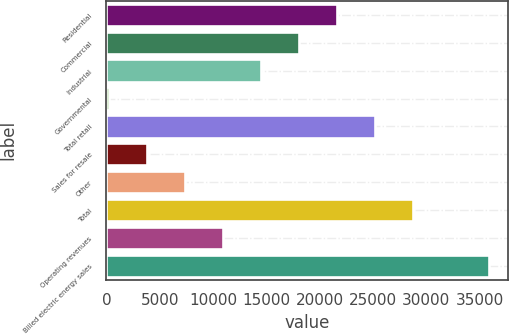<chart> <loc_0><loc_0><loc_500><loc_500><bar_chart><fcel>Residential<fcel>Commercial<fcel>Industrial<fcel>Governmental<fcel>Total retail<fcel>Sales for resale<fcel>Other<fcel>Total<fcel>Operating revenues<fcel>Billed electric energy sales<nl><fcel>21615.4<fcel>18049<fcel>14482.6<fcel>217<fcel>25181.8<fcel>3783.4<fcel>7349.8<fcel>28748.2<fcel>10916.2<fcel>35881<nl></chart> 